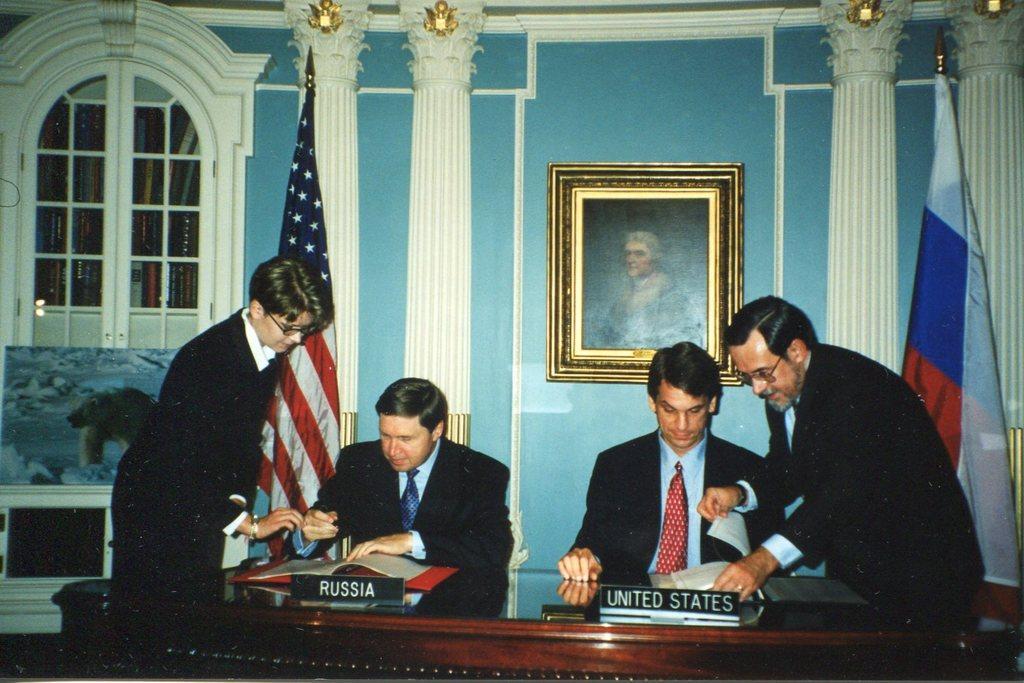How would you summarize this image in a sentence or two? In-front of these people there is a table with state name boards and files. Picture is on the wall. In-front of these pillars there are flags. In this race there are book. Here we can see a painting. 